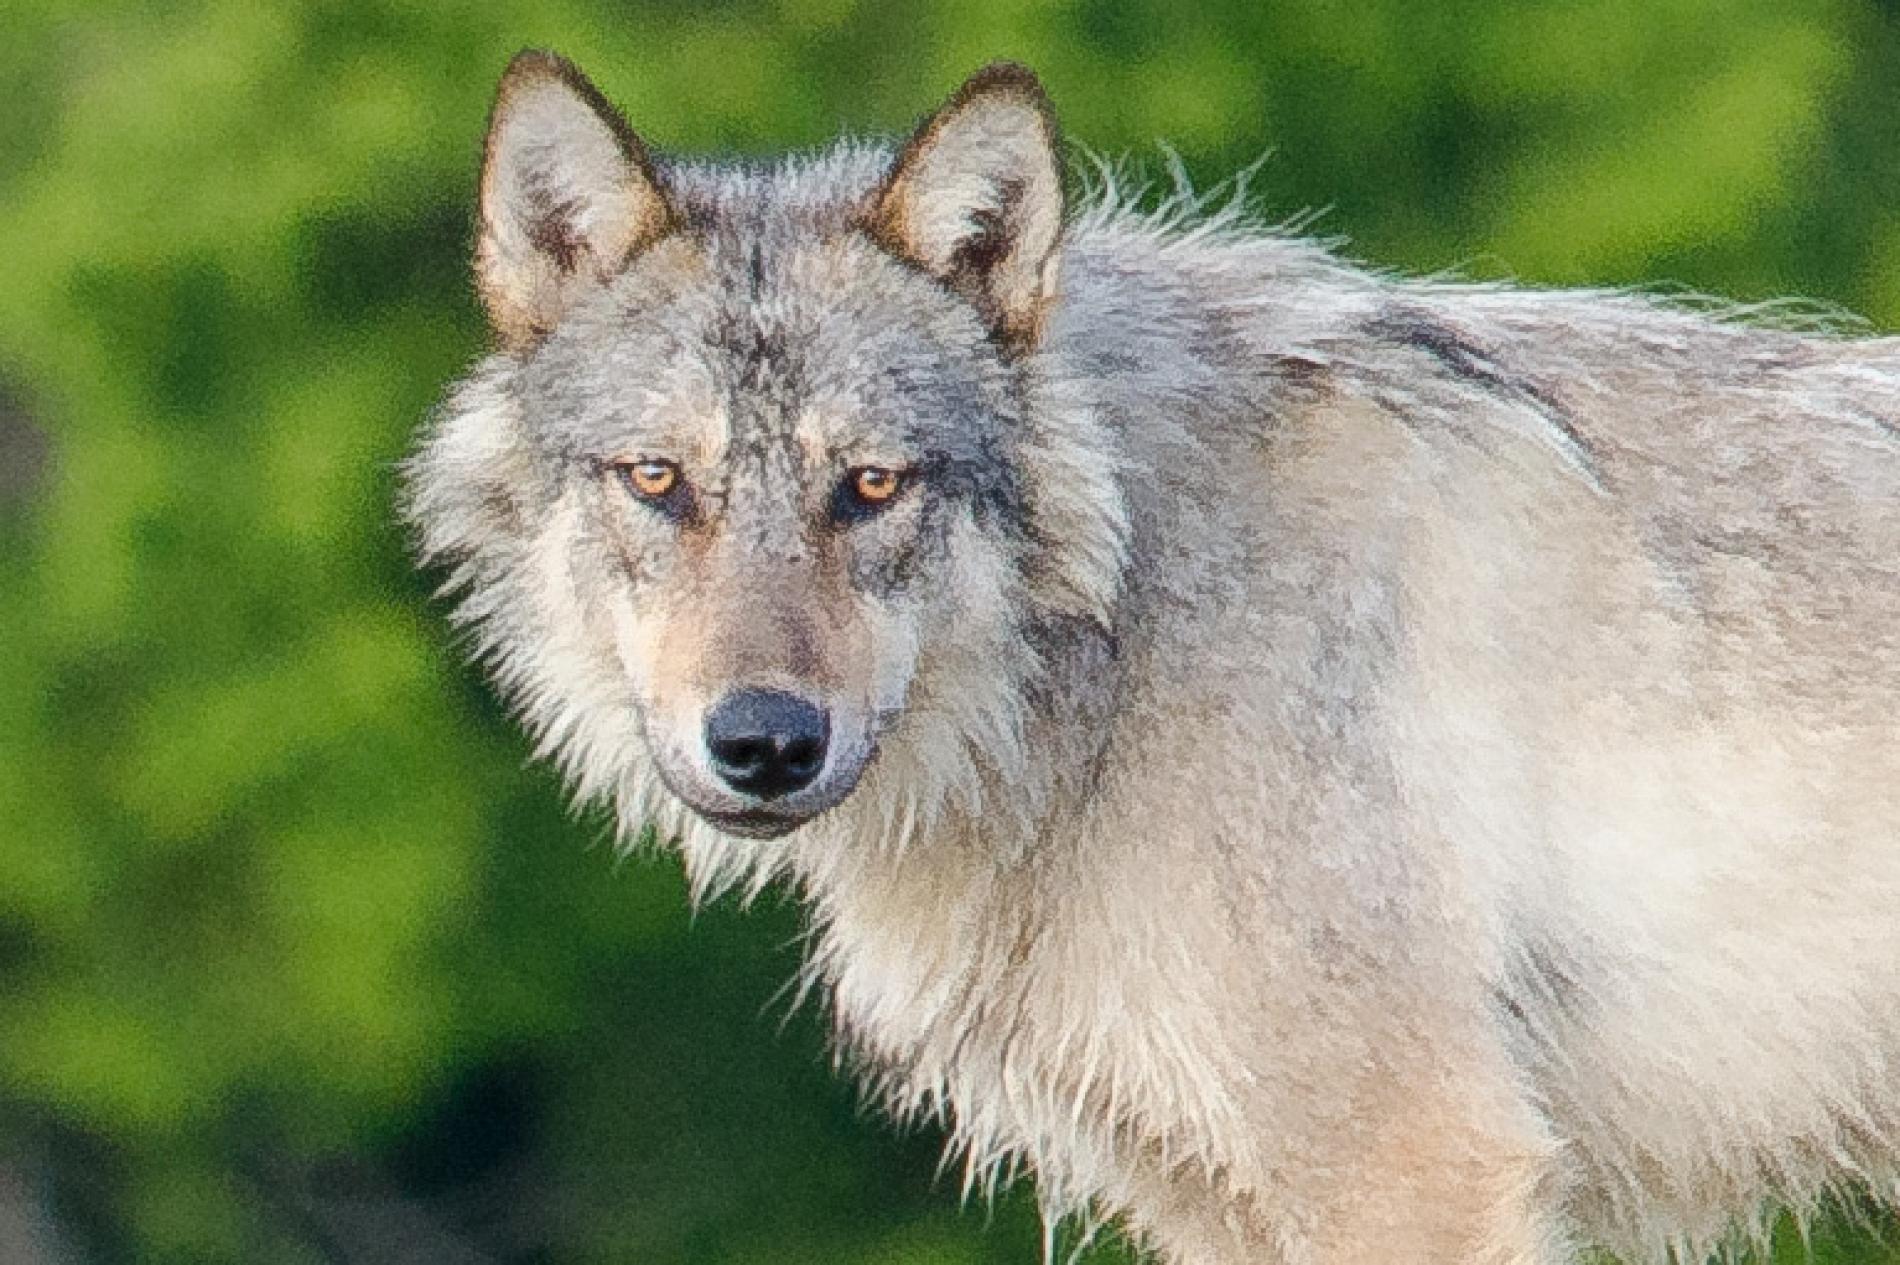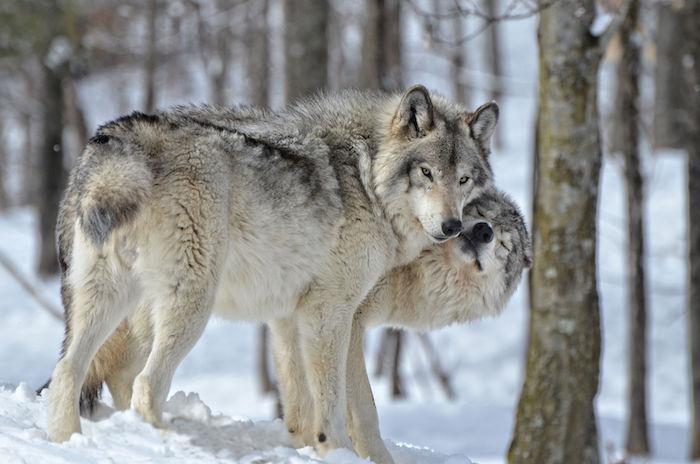The first image is the image on the left, the second image is the image on the right. Analyze the images presented: Is the assertion "At least one image shows a wolf in a snowy scene." valid? Answer yes or no. Yes. 